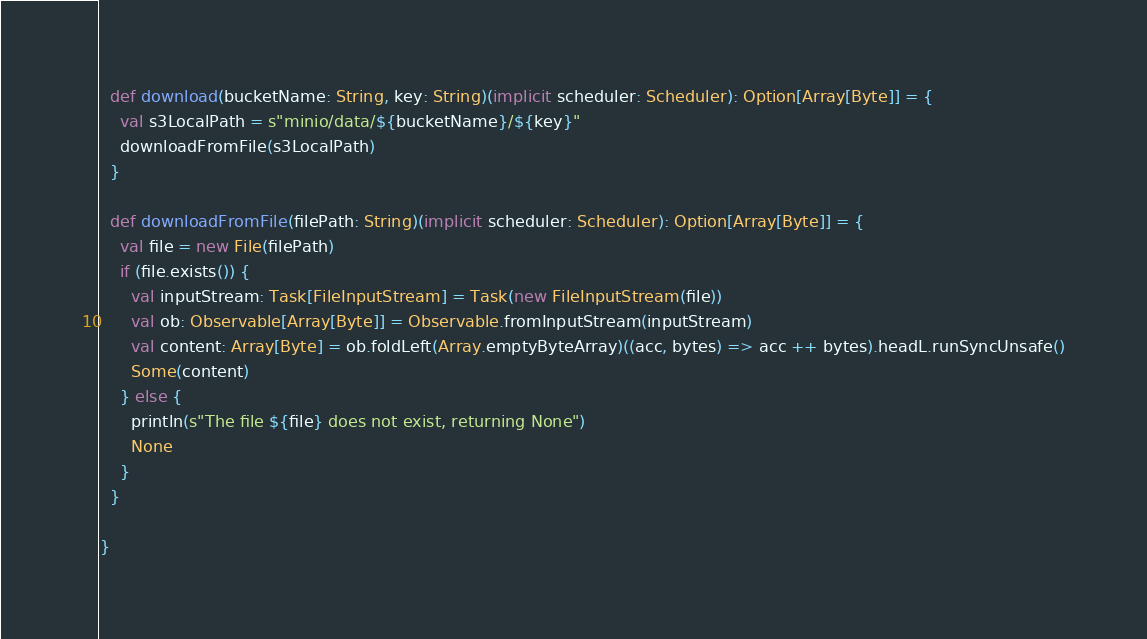Convert code to text. <code><loc_0><loc_0><loc_500><loc_500><_Scala_>
  def download(bucketName: String, key: String)(implicit scheduler: Scheduler): Option[Array[Byte]] = {
    val s3LocalPath = s"minio/data/${bucketName}/${key}"
    downloadFromFile(s3LocalPath)
  }

  def downloadFromFile(filePath: String)(implicit scheduler: Scheduler): Option[Array[Byte]] = {
    val file = new File(filePath)
    if (file.exists()) {
      val inputStream: Task[FileInputStream] = Task(new FileInputStream(file))
      val ob: Observable[Array[Byte]] = Observable.fromInputStream(inputStream)
      val content: Array[Byte] = ob.foldLeft(Array.emptyByteArray)((acc, bytes) => acc ++ bytes).headL.runSyncUnsafe()
      Some(content)
    } else {
      println(s"The file ${file} does not exist, returning None")
      None
    }
  }

}
</code> 